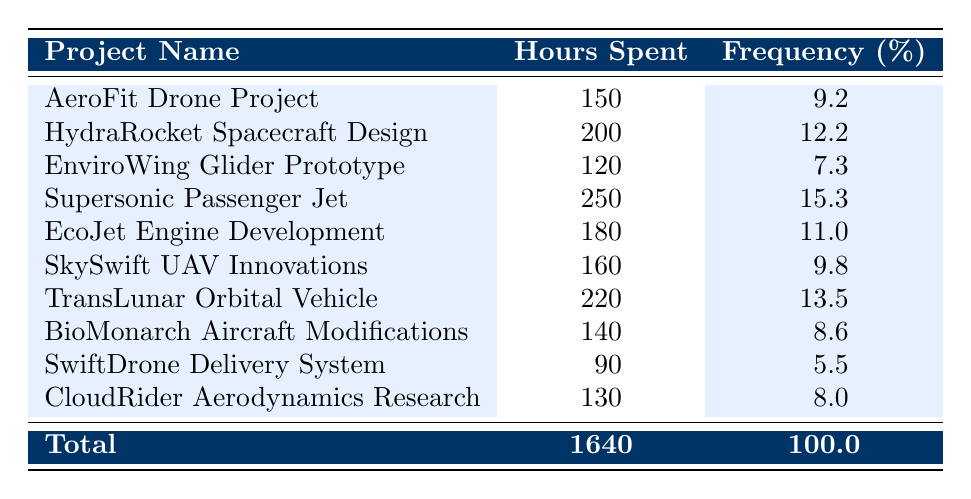What is the total number of hours spent across all projects? The table lists individual hours spent on each project. By summing them up: 150 + 200 + 120 + 250 + 180 + 160 + 220 + 140 + 90 + 130 = 1640 hours.
Answer: 1640 Which project spent the most hours on design? The table indicates that the project with the highest hours spent is the Supersonic Passenger Jet with 250 hours.
Answer: Supersonic Passenger Jet What percentage of the total hours was spent on the EcoJet Engine Development project? The EcoJet Engine Development project spent 180 hours. To find its percentage of total hours: (180/1640) * 100 = 11.0%.
Answer: 11.0% How many projects spent more than 200 hours on design? The only project that spent more than 200 hours is the Supersonic Passenger Jet (250 hours) and the TransLunar Orbital Vehicle (220 hours). Thus, there are 2 projects in total.
Answer: 2 Is it true that the HydraroRocket Spacecraft Design project had a higher percentage of total hours than the CloudRider Aerodynamics Research? The table shows that HydraRocket Spacecraft Design had 12.2% of total hours, while CloudRider Aerodynamics Research had only 8.0%. Therefore, the statement is true.
Answer: Yes What is the average number of hours spent on all projects? To find the average, sum the total hours (1640) and divide by the number of projects (10): 1640/10 = 164.
Answer: 164 Which project has the lowest percentage of total hours spent? According to the table, the SwiftDrone Delivery System spent 90 hours, which is 5.5% of the total hours, making it the lowest percentage among all projects.
Answer: SwiftDrone Delivery System What is the combined total percentage of hours spent on projects that spent between 150 and 200 hours? The projects in this range are AeroFit Drone Project (9.2%), EcoJet Engine Development (11.0%), and SkySwift UAV Innovations (9.8%). Adding them gives: 9.2 + 11.0 + 9.8 = 30.0%.
Answer: 30.0% 